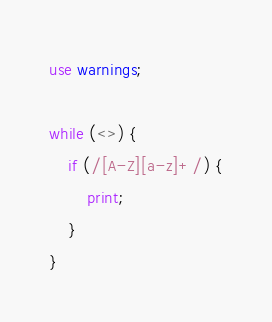<code> <loc_0><loc_0><loc_500><loc_500><_Perl_>use warnings;

while (<>) {
    if (/[A-Z][a-z]+/) {
        print;
    }
}
</code> 